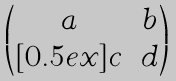Convert formula to latex. <formula><loc_0><loc_0><loc_500><loc_500>\begin{pmatrix} a & b \\ [ 0 . 5 e x ] c & d \end{pmatrix}</formula> 